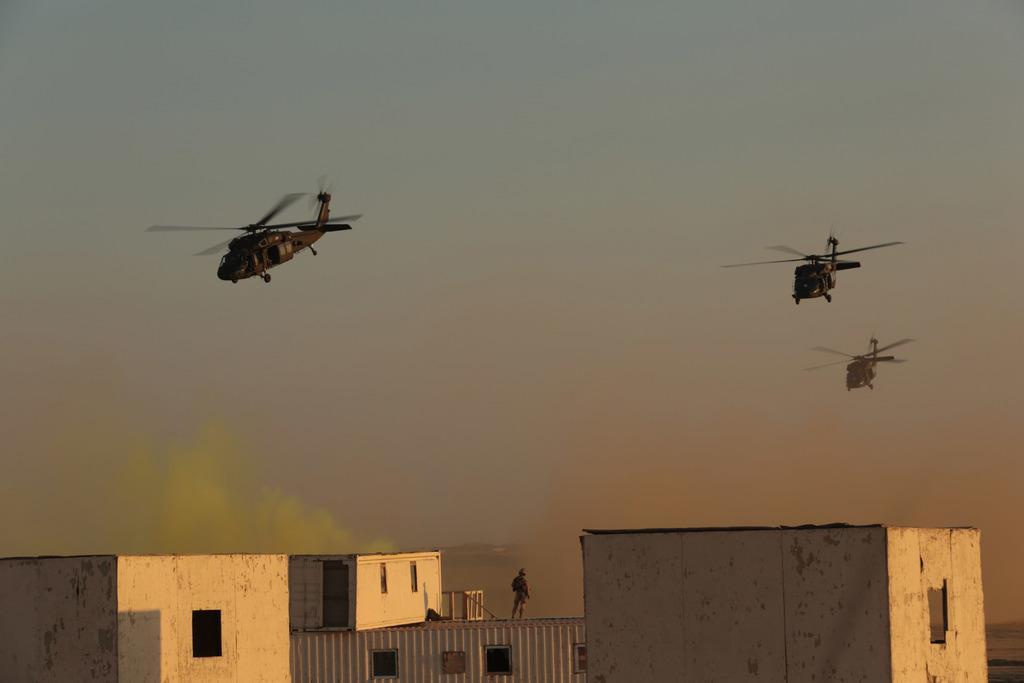Can you describe this image briefly? In this image there are three helicopters in the sky. At the bottom of the image there are buildings, on the one of the buildings there is a person standing. 